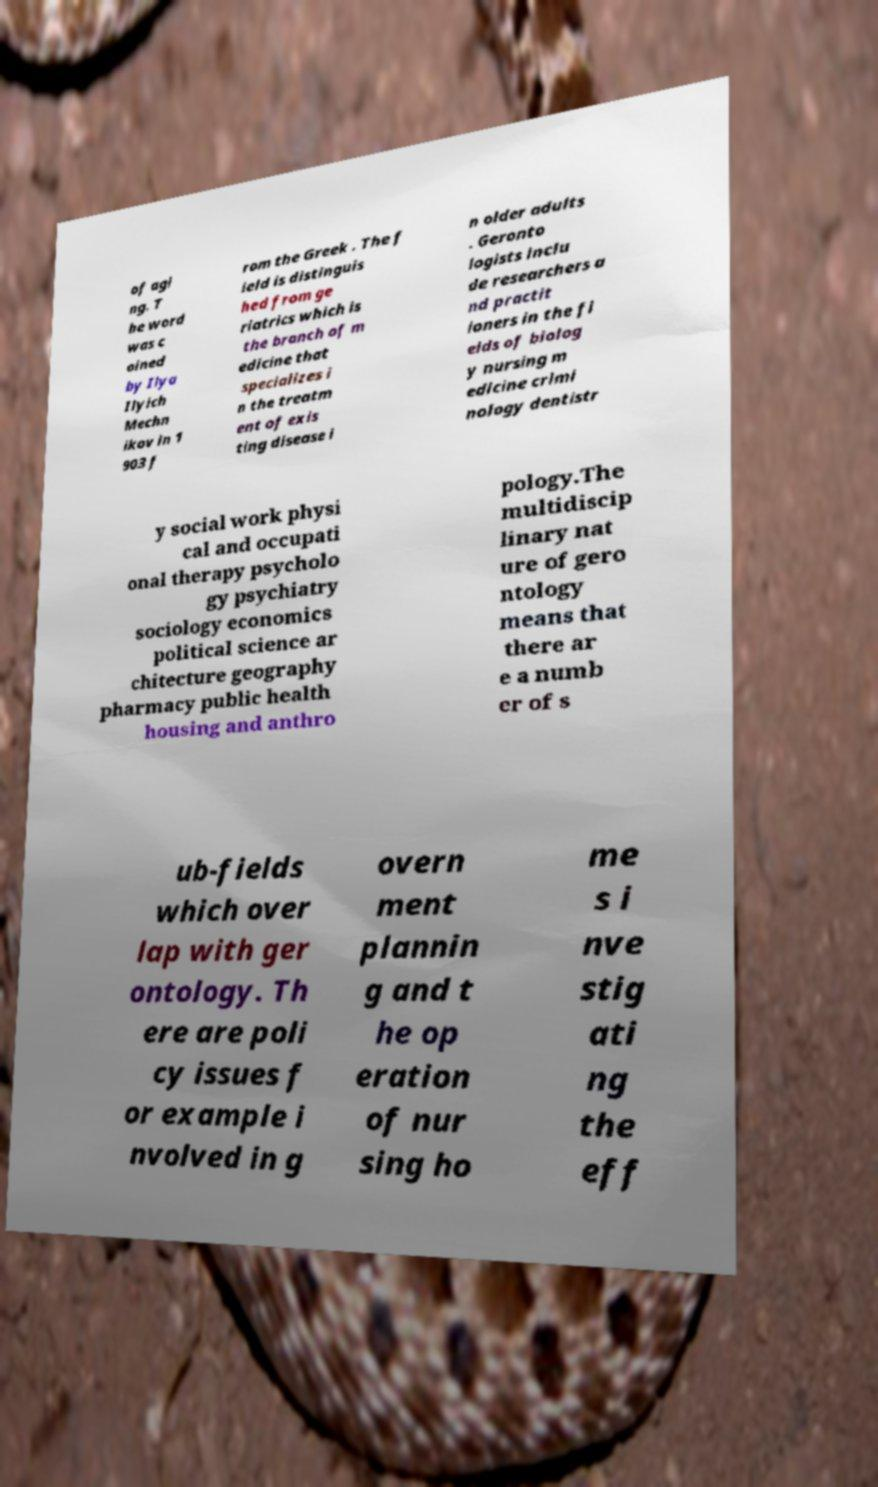Could you extract and type out the text from this image? of agi ng. T he word was c oined by Ilya Ilyich Mechn ikov in 1 903 f rom the Greek . The f ield is distinguis hed from ge riatrics which is the branch of m edicine that specializes i n the treatm ent of exis ting disease i n older adults . Geronto logists inclu de researchers a nd practit ioners in the fi elds of biolog y nursing m edicine crimi nology dentistr y social work physi cal and occupati onal therapy psycholo gy psychiatry sociology economics political science ar chitecture geography pharmacy public health housing and anthro pology.The multidiscip linary nat ure of gero ntology means that there ar e a numb er of s ub-fields which over lap with ger ontology. Th ere are poli cy issues f or example i nvolved in g overn ment plannin g and t he op eration of nur sing ho me s i nve stig ati ng the eff 